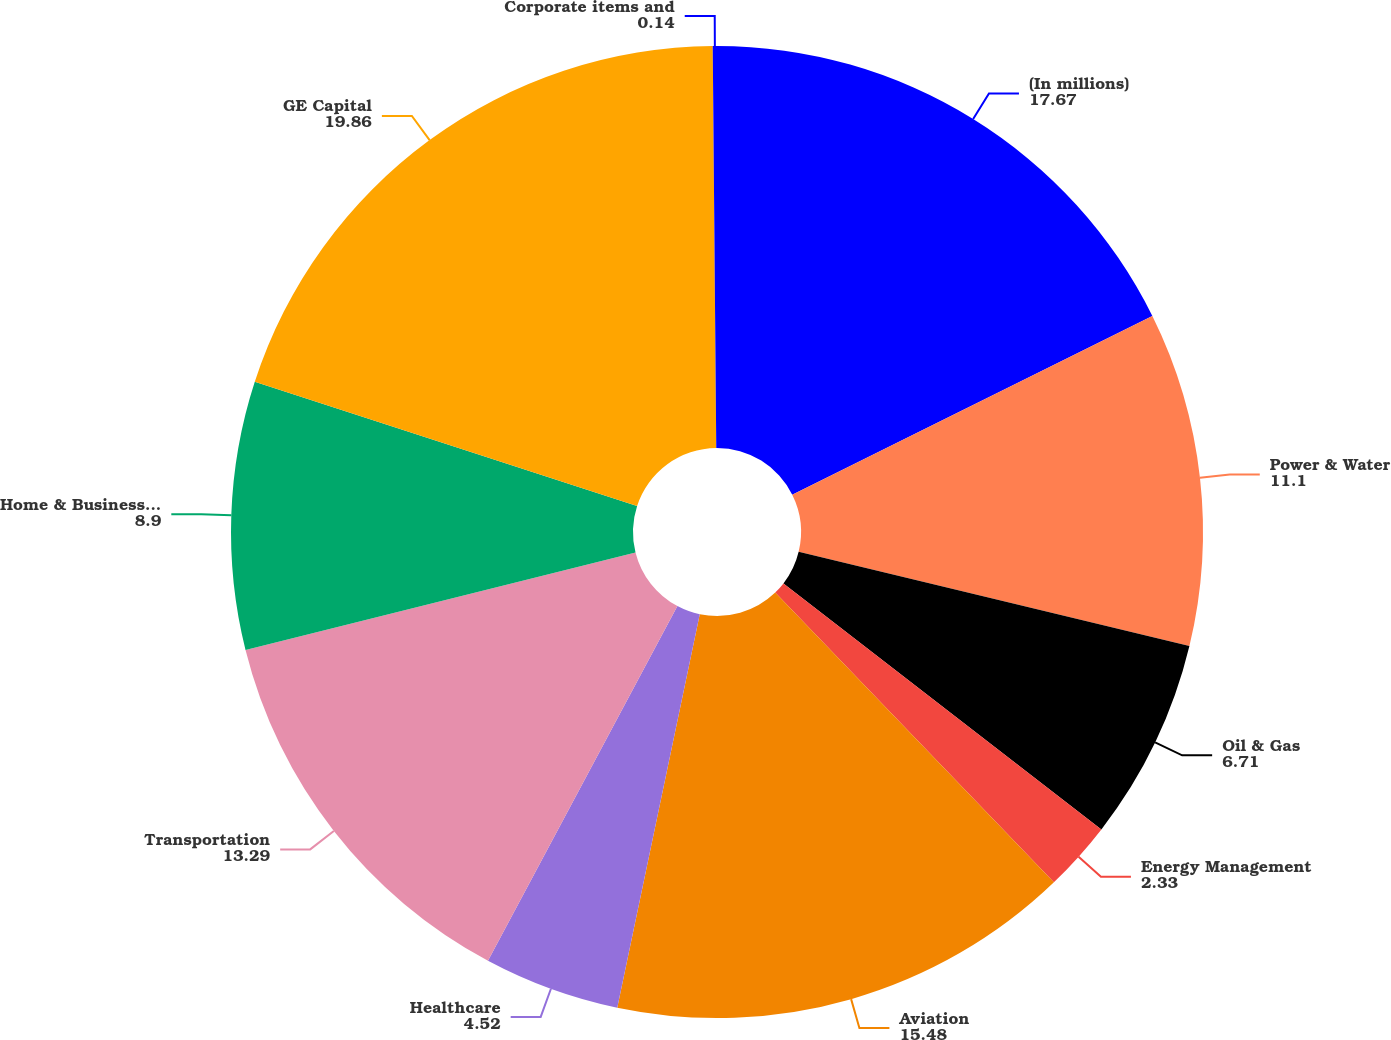Convert chart. <chart><loc_0><loc_0><loc_500><loc_500><pie_chart><fcel>(In millions)<fcel>Power & Water<fcel>Oil & Gas<fcel>Energy Management<fcel>Aviation<fcel>Healthcare<fcel>Transportation<fcel>Home & Business Solutions<fcel>GE Capital<fcel>Corporate items and<nl><fcel>17.67%<fcel>11.1%<fcel>6.71%<fcel>2.33%<fcel>15.48%<fcel>4.52%<fcel>13.29%<fcel>8.9%<fcel>19.86%<fcel>0.14%<nl></chart> 